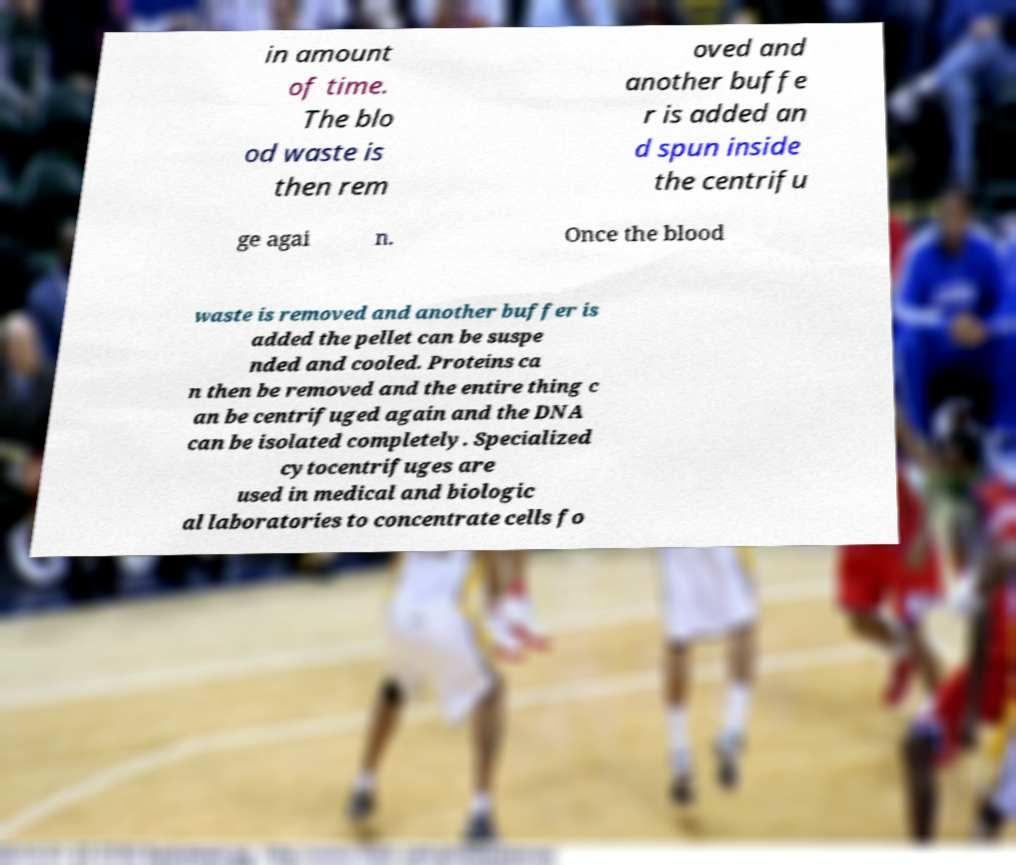There's text embedded in this image that I need extracted. Can you transcribe it verbatim? in amount of time. The blo od waste is then rem oved and another buffe r is added an d spun inside the centrifu ge agai n. Once the blood waste is removed and another buffer is added the pellet can be suspe nded and cooled. Proteins ca n then be removed and the entire thing c an be centrifuged again and the DNA can be isolated completely. Specialized cytocentrifuges are used in medical and biologic al laboratories to concentrate cells fo 